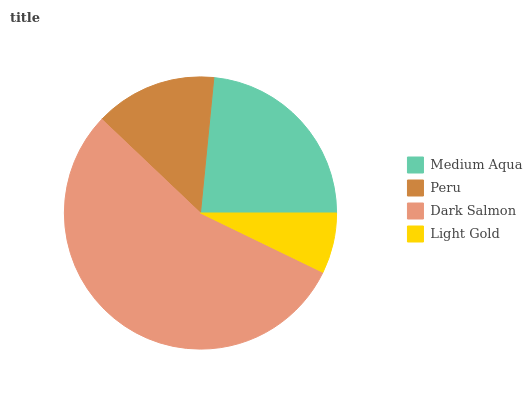Is Light Gold the minimum?
Answer yes or no. Yes. Is Dark Salmon the maximum?
Answer yes or no. Yes. Is Peru the minimum?
Answer yes or no. No. Is Peru the maximum?
Answer yes or no. No. Is Medium Aqua greater than Peru?
Answer yes or no. Yes. Is Peru less than Medium Aqua?
Answer yes or no. Yes. Is Peru greater than Medium Aqua?
Answer yes or no. No. Is Medium Aqua less than Peru?
Answer yes or no. No. Is Medium Aqua the high median?
Answer yes or no. Yes. Is Peru the low median?
Answer yes or no. Yes. Is Dark Salmon the high median?
Answer yes or no. No. Is Light Gold the low median?
Answer yes or no. No. 